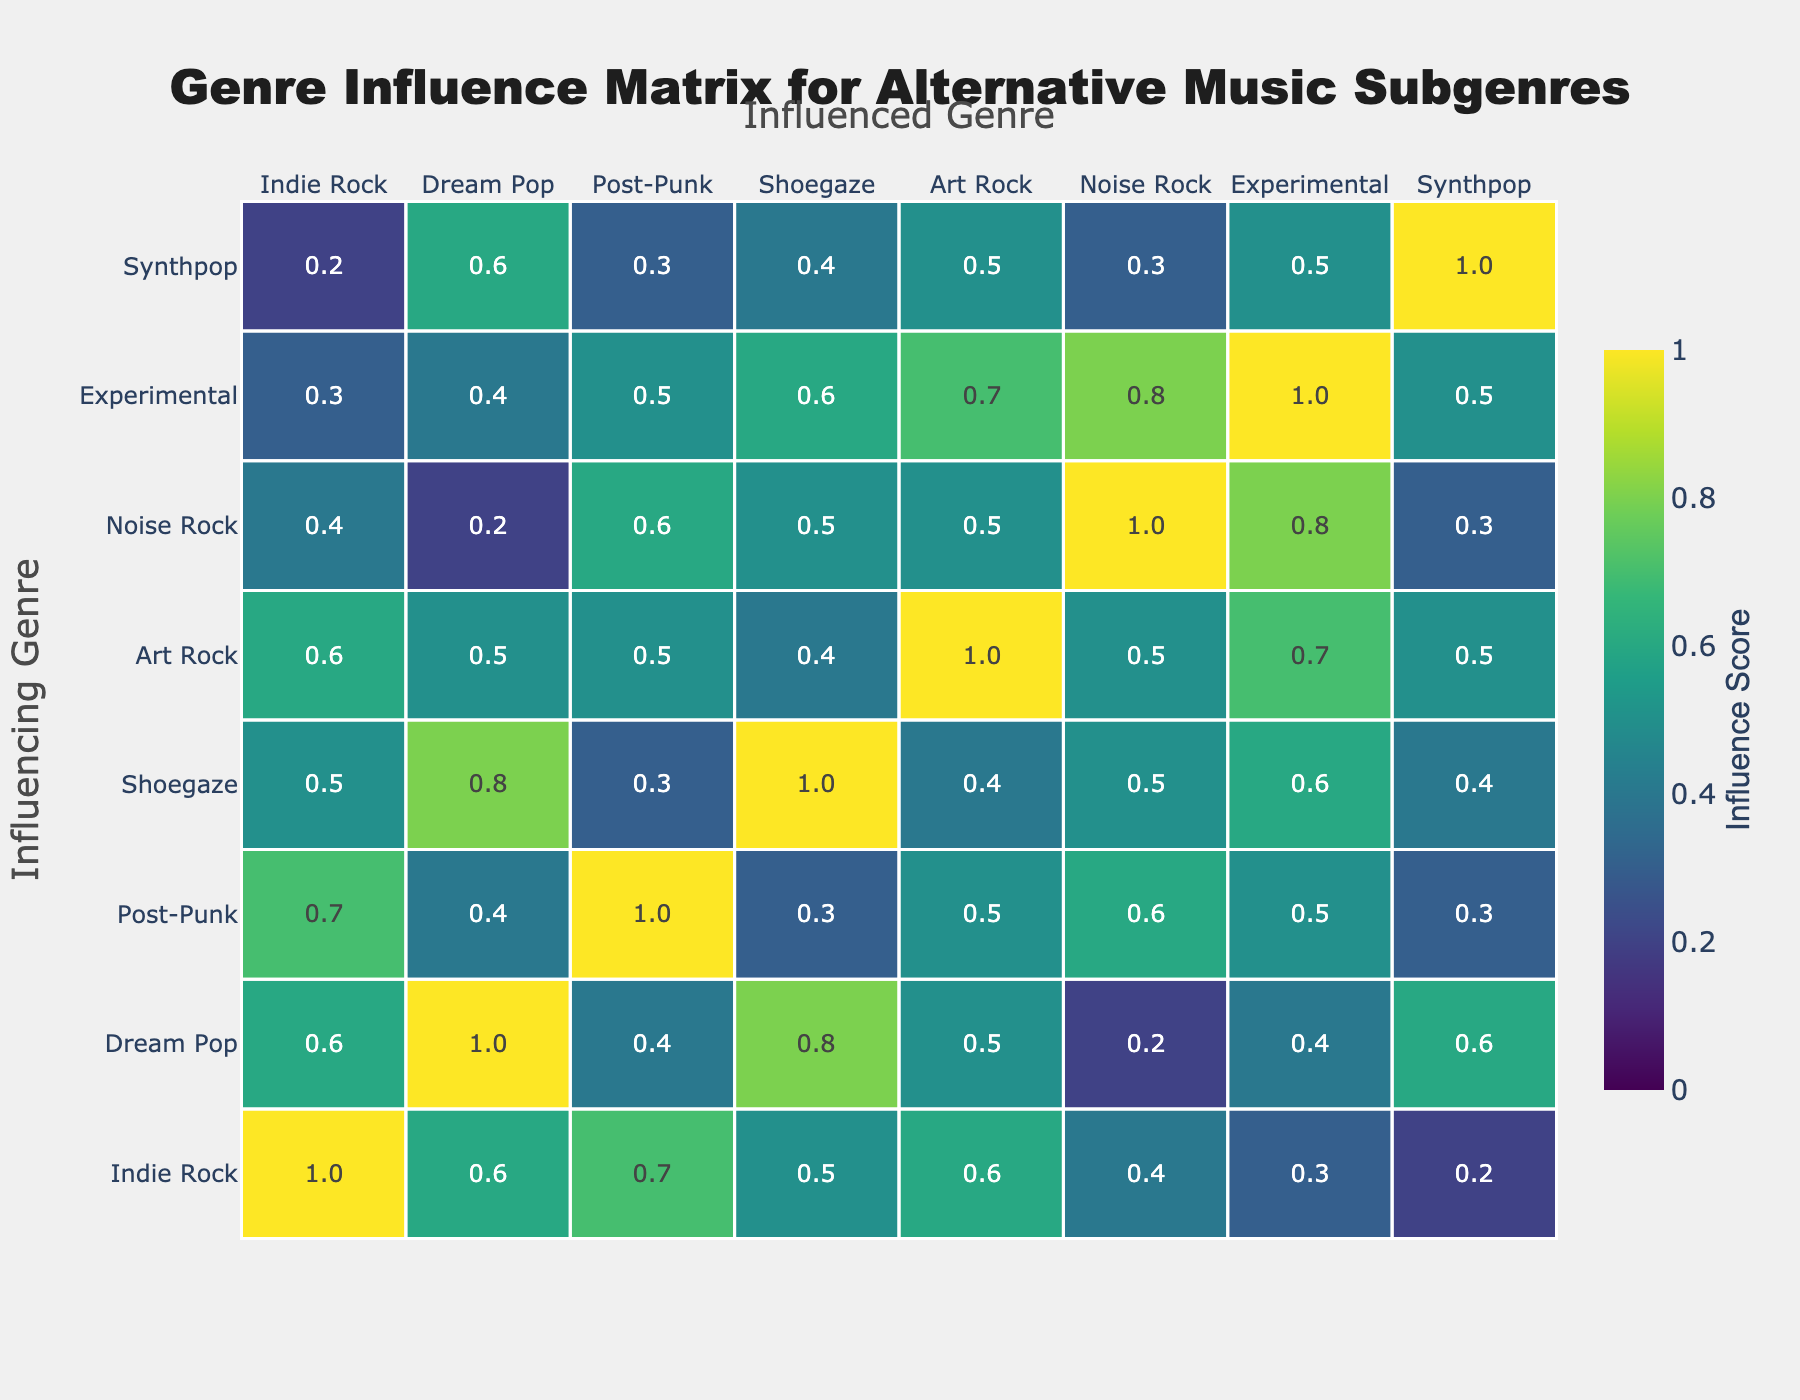What is the influence score of Indie Rock on Dream Pop? The influence score can be found in the cell at the intersection of the Indie Rock row and Dream Pop column. The score is 0.6.
Answer: 0.6 Which genre has the highest influence score on Synthpop? Looking at the Synthpop column, the highest influence score is 0.6 from Dream Pop.
Answer: Dream Pop Is Noise Rock the genre that has the least influence on Art Rock? Checking the Noise Rock row for the Art Rock column, the score is 0.5, which is not the lowest (Indie Rock and Dream Pop both have lower scores of 0.4 and 0.2 respectively). Therefore, it is false that Noise Rock has the least influence on Art Rock.
Answer: No What is the average influence score of Post-Punk on all other genres? Adding the influence scores in the Post-Punk row: 0.7 (Indie Rock) + 0.4 (Dream Pop) + 1.0 (Post-Punk) + 0.3 (Shoegaze) + 0.5 (Art Rock) + 0.6 (Noise Rock) + 0.5 (Experimental) + 0.3 (Synthpop) = 3.9. There are 8 scores, so the average is 3.9 / 8 = 0.4875.
Answer: 0.4875 Which genre has the most consistent influence score across the board? To determine consistency, we can observe the range (difference between highest and lowest scores) for each genre. Experimental has scores ranging from 0.3 to 1.0 (range = 0.7), whereas others like Art Rock have scores from 0.5 to 0.7 (range = 0.2). Finding the one with the smallest range, Art Rock appears to be the most consistent.
Answer: Art Rock What is the difference between the highest and lowest influence score of Shoegaze on other genres? The highest influence score from the Shoegaze row is 0.8 (Dream Pop) and the lowest is 0.3 (Post-Punk). The difference is 0.8 - 0.3 = 0.5.
Answer: 0.5 How does the influence of Dream Pop on Post-Punk compare to its influence on Synthpop? Looking at Dream Pop's row: its influence on Post-Punk is 0.4 while its influence on Synthpop is 0.6. Since 0.6 is greater than 0.4, Dream Pop has a stronger influence on Synthpop.
Answer: Stronger on Synthpop If you sum the influence scores of Noise Rock, what would you get? Adding the scores from the Noise Rock row: 0.4 (Indie Rock) + 0.2 (Dream Pop) + 0.6 (Post-Punk) + 0.5 (Shoegaze) + 0.5 (Art Rock) + 1.0 (Noise Rock) + 0.8 (Experimental) + 0.3 (Synthpop) = 3.9.
Answer: 3.9 Which genre influences Shoegaze the least? In the Shoegaze row, the lowest score is 0.3 (Post-Punk). So, Post-Punk influences Shoegaze the least.
Answer: Post-Punk Does Experimental influence any genre with a score higher than 0.9? Checking the Experimental row, the highest influence score is 1.0 (itself), so it does influence at least that genre with a score of 1.0. Thus, it is true that Experimental influences at least one genre with a score higher than 0.9.
Answer: Yes 